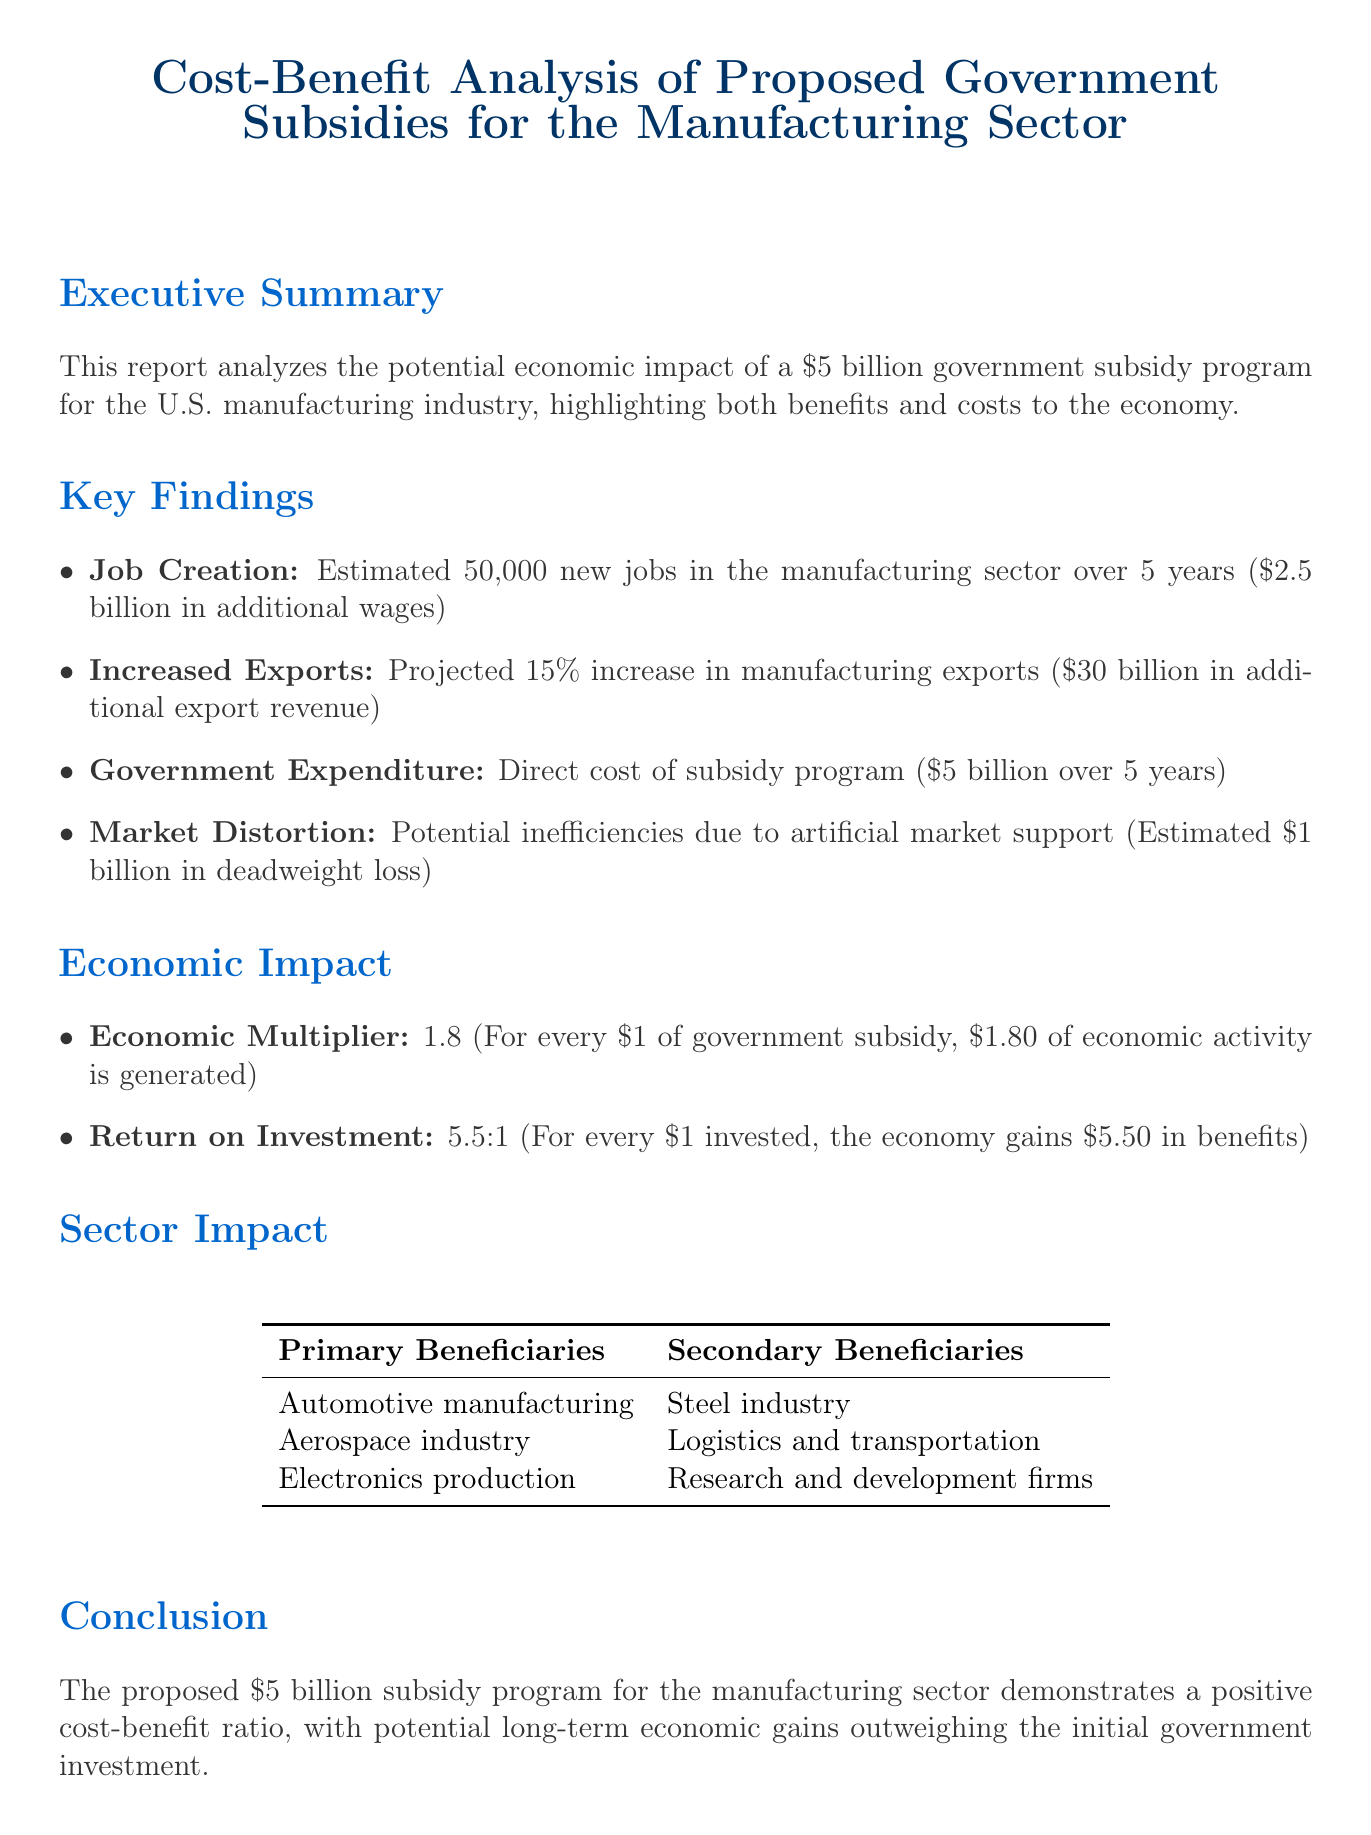What is the total amount of the proposed subsidy? The total amount of the proposed subsidy for the manufacturing sector is stated as $5 billion.
Answer: $5 billion How many new jobs are estimated to be created? The report estimates that 50,000 new jobs will be created in the manufacturing sector over 5 years.
Answer: 50,000 What is the projected increase in manufacturing exports? The projected increase in manufacturing exports is noted as 15%.
Answer: 15% What is the estimated economic multiplier? The economic multiplier is specified as 1.8, meaning every $1 of subsidy generates $1.80 of economic activity.
Answer: 1.8 What is the return on investment ratio? The return on investment is expressed as a ratio of 5.5:1, indicating substantial economic benefits for every dollar invested.
Answer: 5.5:1 What is the economic value of additional export revenue? The document notes that the additional export revenue is projected to be $30 billion.
Answer: $30 billion What are the primary beneficiaries mentioned? The primary beneficiaries listed include automotive manufacturing, aerospace industry, and electronics production.
Answer: Automotive manufacturing, Aerospace industry, Electronics production What is the estimated deadweight loss from market distortion? The estimated deadweight loss from market distortion is stated as $1 billion.
Answer: $1 billion What is the conclusion of the report? The conclusion states that the subsidy program demonstrates a positive cost-benefit ratio with long-term economic gains.
Answer: Positive cost-benefit ratio 